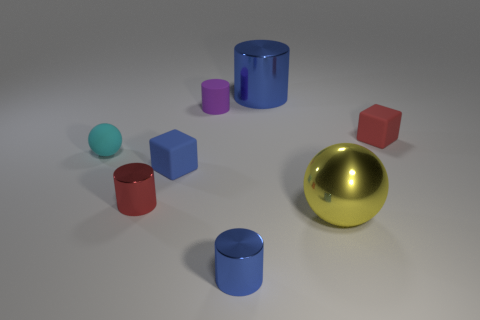Are there any cyan cubes?
Your answer should be compact. No. Do the small blue matte thing and the red matte thing have the same shape?
Offer a very short reply. Yes. How many large blue cylinders are on the left side of the sphere that is on the left side of the big object behind the big yellow metallic ball?
Offer a very short reply. 0. There is a object that is right of the big metal cylinder and on the left side of the small red matte object; what is its material?
Make the answer very short. Metal. There is a object that is both to the right of the large cylinder and behind the small cyan rubber sphere; what color is it?
Provide a succinct answer. Red. Is there any other thing that is the same color as the large shiny cylinder?
Your answer should be compact. Yes. There is a red object that is to the left of the metal cylinder that is behind the small thing on the right side of the big blue shiny cylinder; what shape is it?
Provide a short and direct response. Cylinder. What color is the other matte thing that is the same shape as the blue matte thing?
Offer a very short reply. Red. There is a small cylinder in front of the small red thing left of the big blue metal cylinder; what color is it?
Provide a succinct answer. Blue. There is another blue object that is the same shape as the small blue shiny object; what size is it?
Give a very brief answer. Large. 